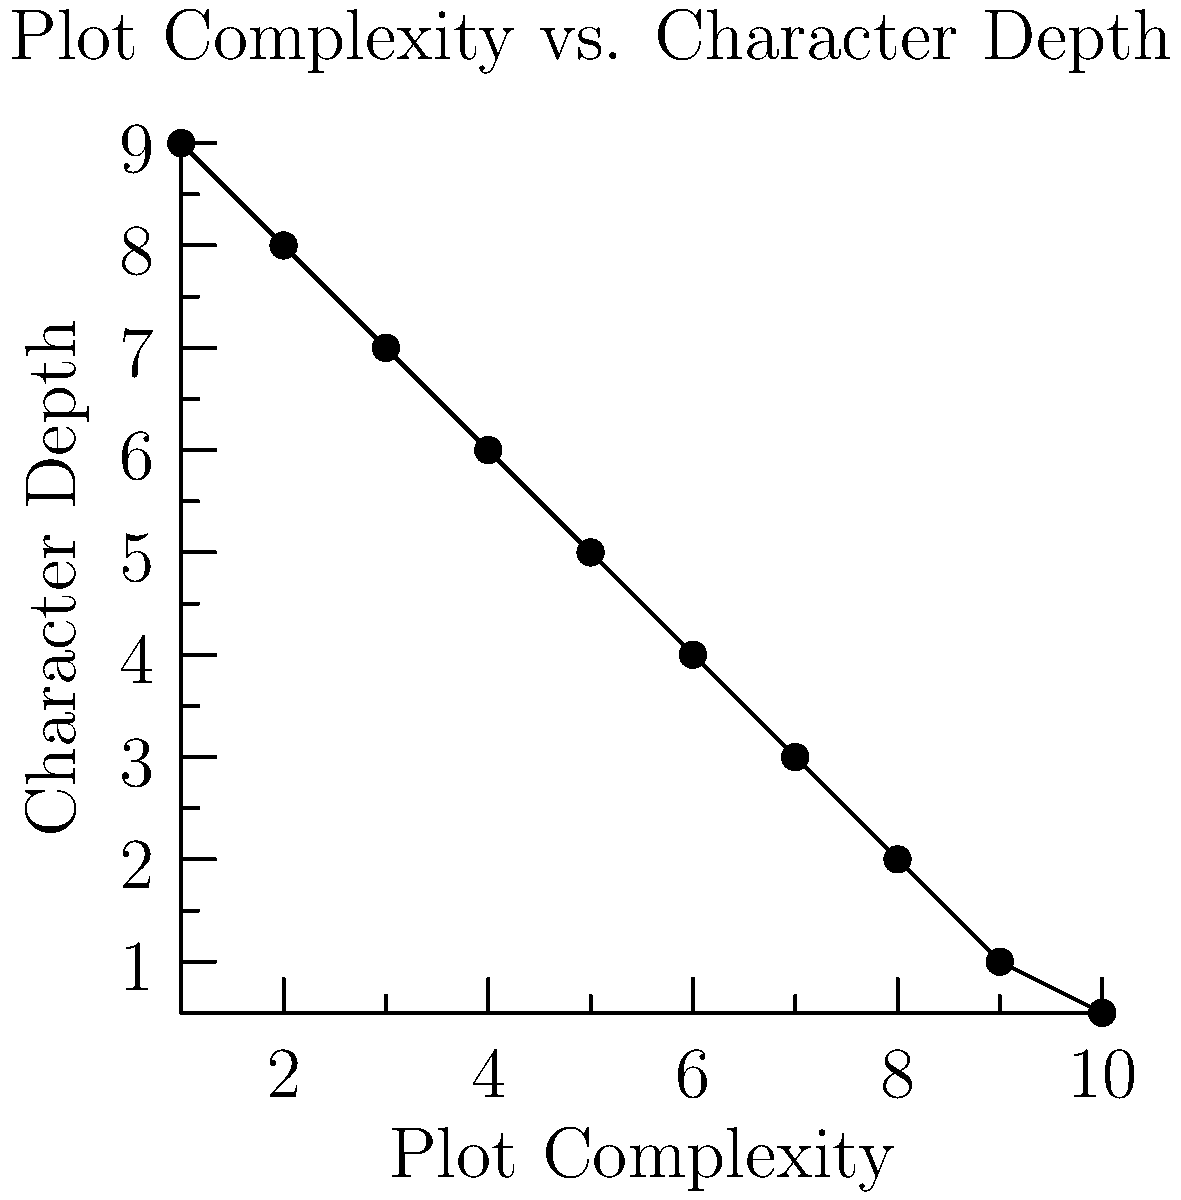Based on the scatter plot showing the relationship between plot complexity and character depth in a series of novels, what trend can be observed, and how does this support or challenge the critic's argument about the author's reliance on plot twists? To answer this question, let's analyze the scatter plot step-by-step:

1. Observe the overall trend: As we move from left to right (increasing plot complexity), the points generally move downward (decreasing character depth).

2. Interpret the relationship: This negative correlation suggests that as plot complexity increases, character depth tends to decrease.

3. Quantify the trend: The relationship appears to be roughly linear, with a strong negative slope.

4. Connect to the critic's argument:
   a) The critic argues that the author's reliance on plot twists distracts from character development.
   b) The scatter plot shows that higher plot complexity (which often involves more plot twists) is associated with lower character depth.

5. Evaluate the evidence: The data in the scatter plot supports the critic's argument by demonstrating a clear inverse relationship between plot complexity and character depth.

6. Consider limitations: While the trend is clear, it's important to note that correlation does not imply causation. Other factors may be influencing this relationship.

7. Conclusion: The scatter plot provides evidence that supports the critic's argument, showing that as the author focuses more on complex plots (potentially including more twists), the depth of character development tends to decrease.
Answer: The scatter plot shows a negative correlation between plot complexity and character depth, supporting the critic's argument that plot twists may detract from character development. 